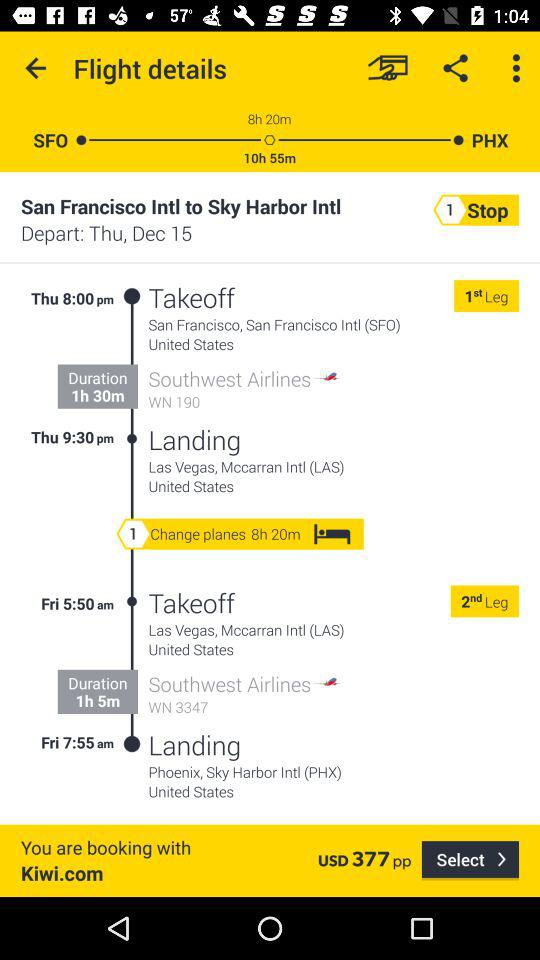How many stops are there? There is 1 stop. 